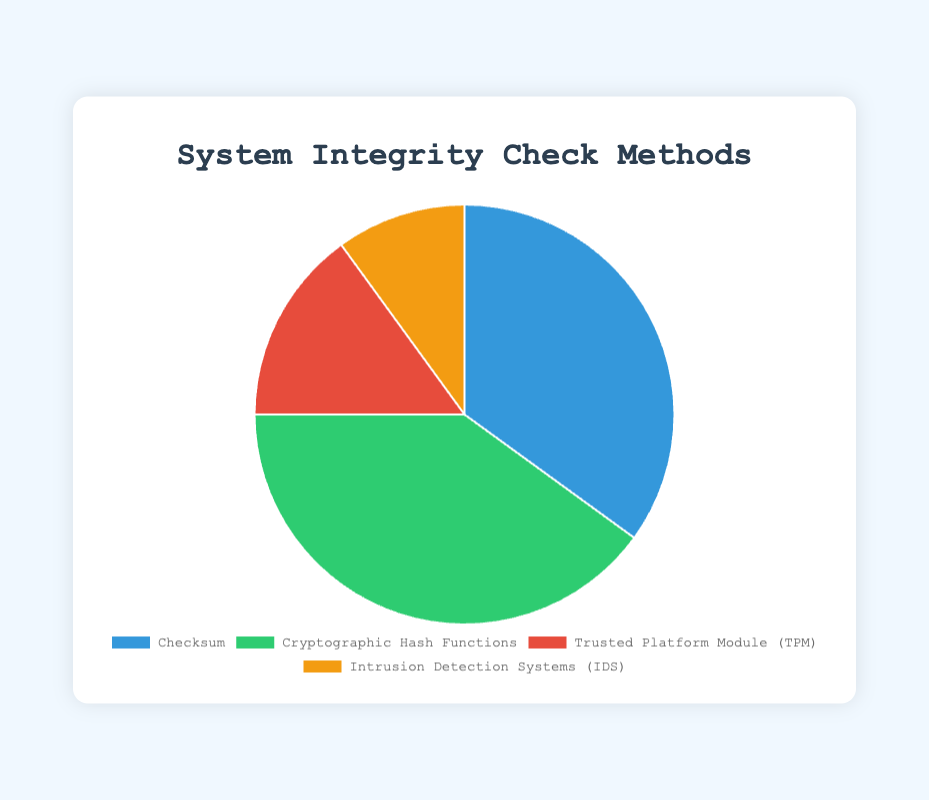What is the most commonly used method for system integrity checks? To determine the most commonly used method, we look for the method with the highest percentage in the pie chart. Cryptographic Hash Functions have the highest percentage at 40%.
Answer: Cryptographic Hash Functions What is the combined percentage of Checksum and Trusted Platform Module (TPM) methods? Summing the percentages of Checksum (35%) and Trusted Platform Module (TPM) (15%) gives us the combined percentage. 35% + 15% = 50%.
Answer: 50% Which method has the smallest proportion in the chart? To find the smallest proportion, we identify the smallest percentage in the pie chart. Intrusion Detection Systems (IDS) has the smallest proportion at 10%.
Answer: Intrusion Detection Systems (IDS) How much larger is the proportion of Cryptographic Hash Functions compared to Intrusion Detection Systems (IDS)? Subtract the percentage of Intrusion Detection Systems (10%) from the percentage of Cryptographic Hash Functions (40%). 40% - 10% = 30%.
Answer: 30% What is the proportion difference between Checksum and Trusted Platform Module (TPM)? Subtract the percentage of Trusted Platform Module (15%) from the percentage of Checksum (35%). 35% - 15% = 20%.
Answer: 20% What colors represent Checksum and Cryptographic Hash Functions in the chart? The colors used for Checksum and Cryptographic Hash Functions must be identified visually on the pie chart. Checksum is blue and Cryptographic Hash Functions is green.
Answer: Blue and Green Which two methods together make up exactly half of the system integrity checks? Identify two methods whose combined percentage is 50%. Combining Checksum (35%) and Trusted Platform Module (15%) gives us 50%.
Answer: Checksum and Trusted Platform Module (TPM) If 5 more studies used IDS, making its total 15%, how does this affect its ranking? Adding 5% to Intrusion Detection Systems (IDS) gives it a new percentage of 15%. This ties it with Trusted Platform Module (TPM) at 15%, making it tied for third place.
Answer: Tied for third place Which method has a red color representation in the chart? Identify visually the method represented by the red color. Trusted Platform Module (TPM) is depicted in red.
Answer: Trusted Platform Module (TPM) How many methods have a proportion greater than 30%? Identify the methods whose proportions are greater than 30%. Checksum is 35% and Cryptographic Hash Functions is 40%. There are 2 methods.
Answer: 2 methods 